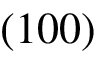<formula> <loc_0><loc_0><loc_500><loc_500>( 1 0 0 )</formula> 